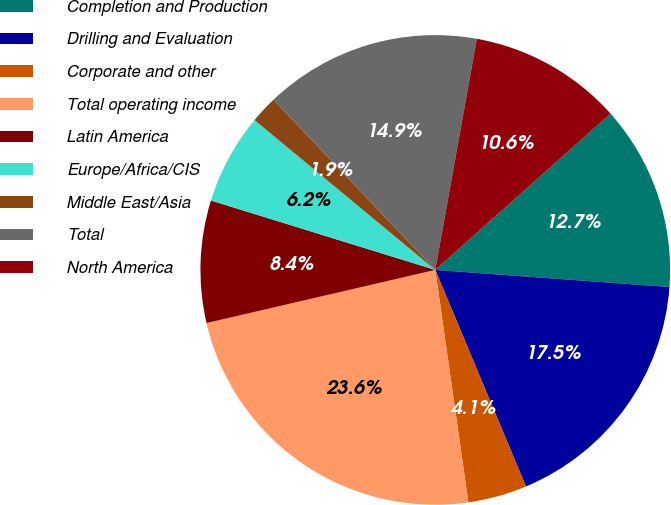<chart> <loc_0><loc_0><loc_500><loc_500><pie_chart><fcel>Completion and Production<fcel>Drilling and Evaluation<fcel>Corporate and other<fcel>Total operating income<fcel>Latin America<fcel>Europe/Africa/CIS<fcel>Middle East/Asia<fcel>Total<fcel>North America<nl><fcel>12.75%<fcel>17.53%<fcel>4.06%<fcel>23.62%<fcel>8.41%<fcel>6.24%<fcel>1.89%<fcel>14.93%<fcel>10.58%<nl></chart> 